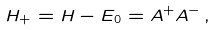Convert formula to latex. <formula><loc_0><loc_0><loc_500><loc_500>H _ { + } = H - E _ { 0 } = A ^ { + } A ^ { - } \, ,</formula> 